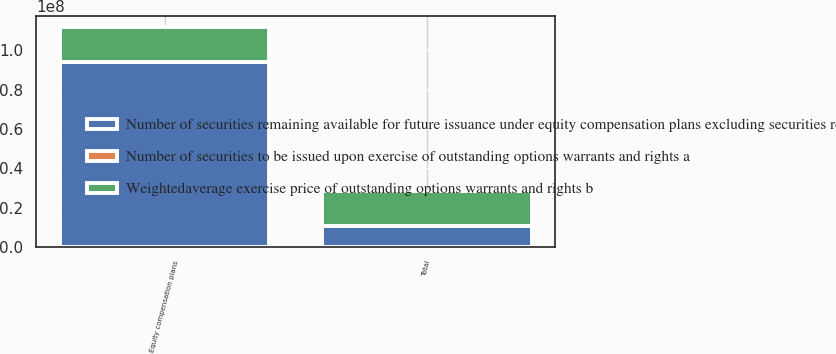<chart> <loc_0><loc_0><loc_500><loc_500><stacked_bar_chart><ecel><fcel>Equity compensation plans<fcel>Total<nl><fcel>Number of securities remaining available for future issuance under equity compensation plans excluding securities reflected in column a c<fcel>9.38943e+07<fcel>1.05093e+07<nl><fcel>Number of securities to be issued upon exercise of outstanding options warrants and rights a<fcel>65.37<fcel>64.22<nl><fcel>Weightedaverage exercise price of outstanding options warrants and rights b<fcel>1.80964e+07<fcel>1.80964e+07<nl></chart> 